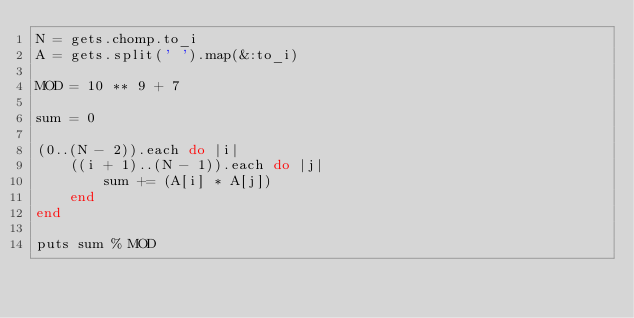Convert code to text. <code><loc_0><loc_0><loc_500><loc_500><_Ruby_>N = gets.chomp.to_i
A = gets.split(' ').map(&:to_i)

MOD = 10 ** 9 + 7

sum = 0

(0..(N - 2)).each do |i|
    ((i + 1)..(N - 1)).each do |j|
        sum += (A[i] * A[j])
    end
end

puts sum % MOD</code> 